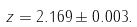<formula> <loc_0><loc_0><loc_500><loc_500>z = 2 . 1 6 9 \pm 0 . 0 0 3 .</formula> 